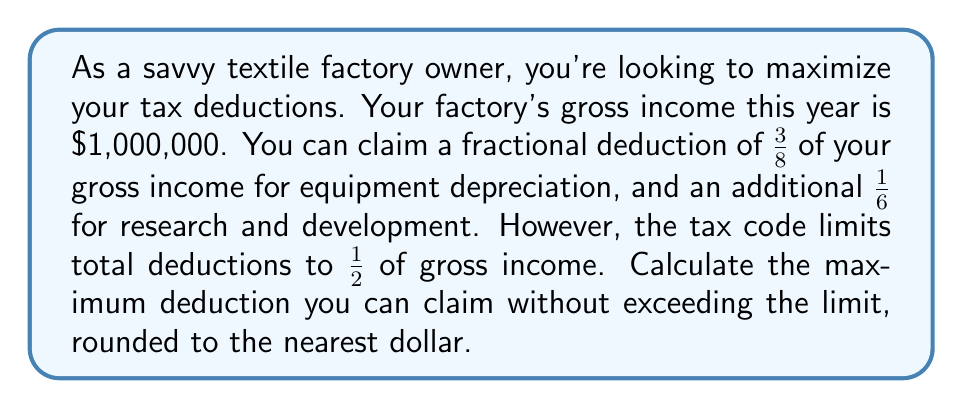Give your solution to this math problem. Let's approach this step-by-step:

1) First, let's calculate the individual deductions:

   Equipment depreciation: $\frac{3}{8}$ of $1,000,000 = $375,000
   Research and development: $\frac{1}{6}$ of $1,000,000 = $166,666.67

2) Now, let's add these deductions:

   $375,000 + $166,666.67 = $541,666.67

3) However, we need to check if this exceeds the limit of $\frac{1}{2}$ of gross income:

   $\frac{1}{2}$ of $1,000,000 = $500,000

4) Our total deductions ($541,666.67) exceed this limit ($500,000).

5) Therefore, the maximum deduction we can claim is $500,000.

6) Rounding to the nearest dollar doesn't change this amount.

This approach allows us to claim the maximum possible deduction without violating the tax code limit.
Answer: $500,000 